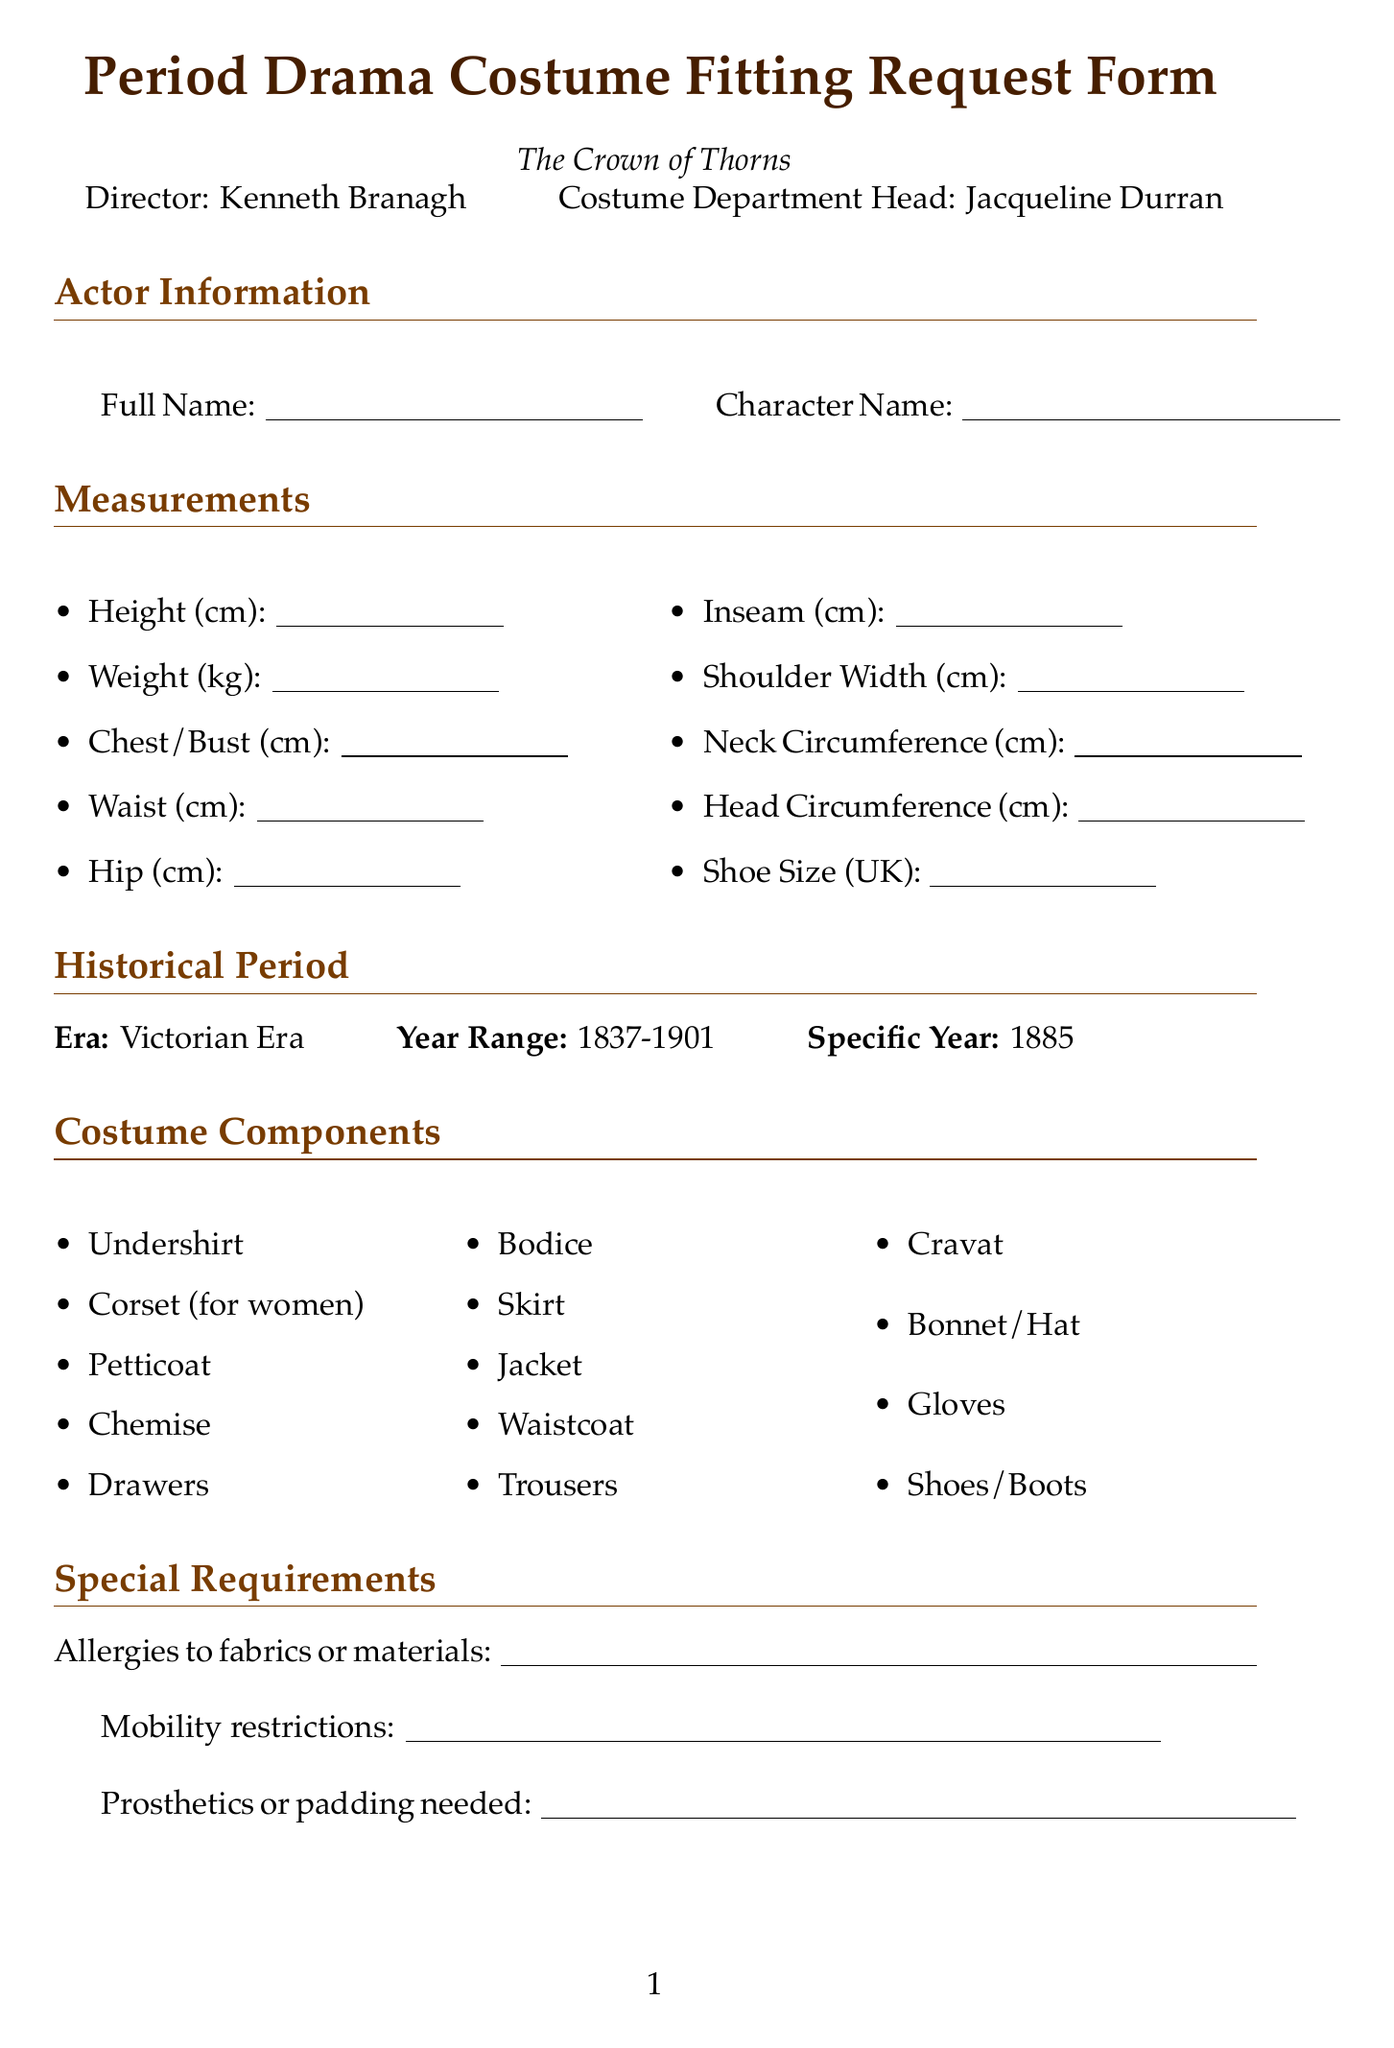What is the title of the production? The title is stated at the top of the document under the form title.
Answer: The Crown of Thorns Who is the director of the film? The director's name is listed in the actor information section of the document.
Answer: Kenneth Branagh What is the specific year of the historical period referenced? The specific year is mentioned under the historical period section of the document.
Answer: 1885 What is the first item listed under costume components? The first item can be found in the list of costume components.
Answer: Undershirt What kind of fabric allergies should be noted in special requirements? This information is requested in the special requirements section of the document.
Answer: Allergies to fabrics or materials What is the location of the fitting schedule? The location for fittings is mentioned at the end of the fitting schedule section.
Answer: Pinewood Studios, Costume Department, Building C Who authored "Victorian Fashions and Costumes from Harper's Bazar, 1867-1898"? The author's name is included beside the title in the historical references section.
Answer: Stella Blum What measurement is not required to be in UK size? The shoe size is specifically noted, and it does not have a unit mentioned.
Answer: Shoe Size How many fittings are mentioned in the schedule? The schedule lists three fittings under the fitting schedule section.
Answer: Three 